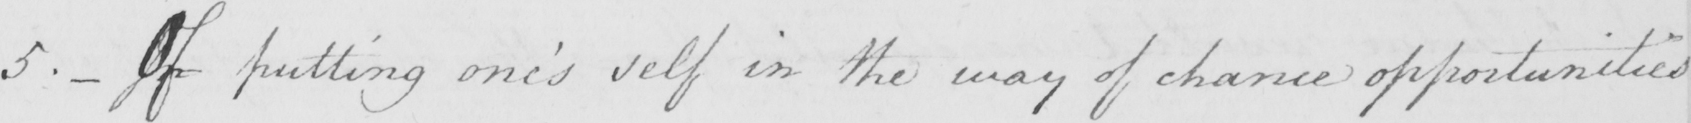Transcribe the text shown in this historical manuscript line. 5 .  _  Of putting one ' s self in the way of chance opportunities 